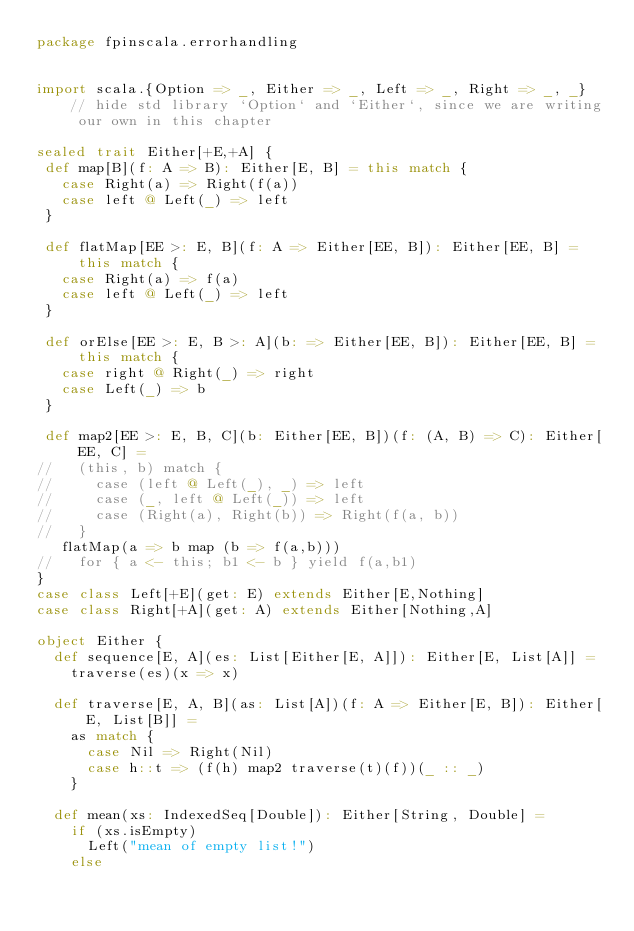Convert code to text. <code><loc_0><loc_0><loc_500><loc_500><_Scala_>package fpinscala.errorhandling


import scala.{Option => _, Either => _, Left => _, Right => _, _} // hide std library `Option` and `Either`, since we are writing our own in this chapter

sealed trait Either[+E,+A] {
 def map[B](f: A => B): Either[E, B] = this match {
   case Right(a) => Right(f(a))
   case left @ Left(_) => left
 }

 def flatMap[EE >: E, B](f: A => Either[EE, B]): Either[EE, B] = this match {
   case Right(a) => f(a)
   case left @ Left(_) => left
 }

 def orElse[EE >: E, B >: A](b: => Either[EE, B]): Either[EE, B] = this match {
   case right @ Right(_) => right
   case Left(_) => b
 }

 def map2[EE >: E, B, C](b: Either[EE, B])(f: (A, B) => C): Either[EE, C] =
//   (this, b) match {
//     case (left @ Left(_), _) => left
//     case (_, left @ Left(_)) => left
//     case (Right(a), Right(b)) => Right(f(a, b))
//   }
   flatMap(a => b map (b => f(a,b)))
//   for { a <- this; b1 <- b } yield f(a,b1)
}
case class Left[+E](get: E) extends Either[E,Nothing]
case class Right[+A](get: A) extends Either[Nothing,A]

object Either {
  def sequence[E, A](es: List[Either[E, A]]): Either[E, List[A]] =
    traverse(es)(x => x)

  def traverse[E, A, B](as: List[A])(f: A => Either[E, B]): Either[E, List[B]] =
    as match {
      case Nil => Right(Nil)
      case h::t => (f(h) map2 traverse(t)(f))(_ :: _)
    }

  def mean(xs: IndexedSeq[Double]): Either[String, Double] = 
    if (xs.isEmpty) 
      Left("mean of empty list!")
    else </code> 